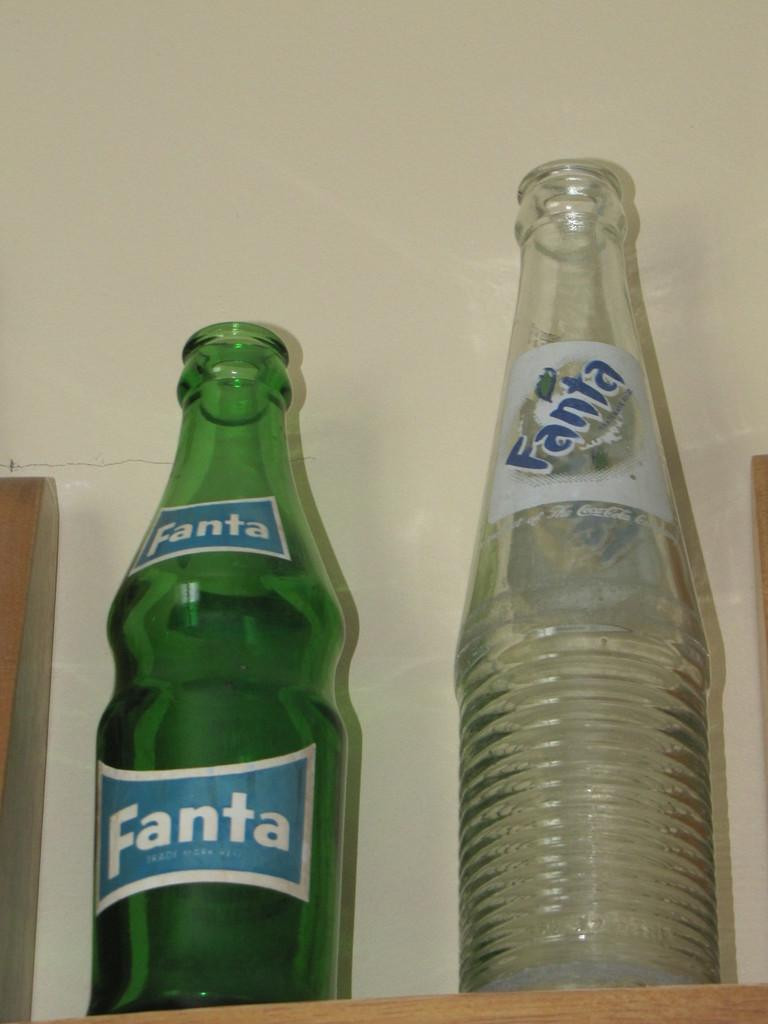<image>
Write a terse but informative summary of the picture. Two empty glass bottles that both have a Fanta label on the front. 